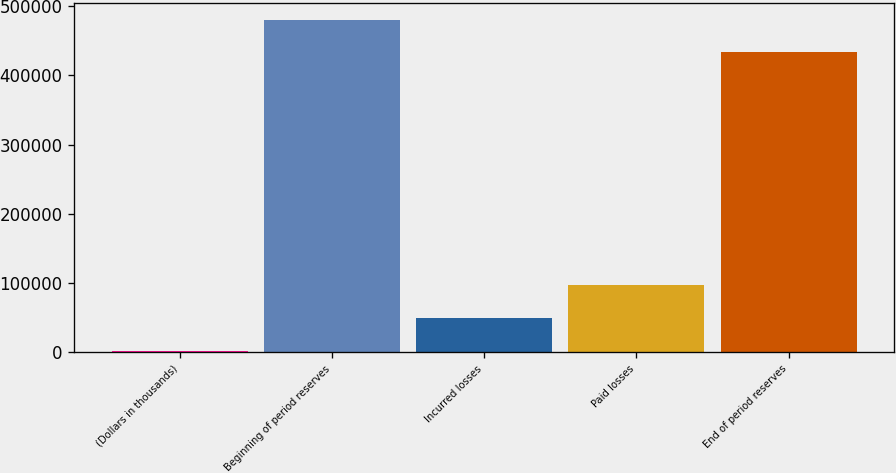Convert chart to OTSL. <chart><loc_0><loc_0><loc_500><loc_500><bar_chart><fcel>(Dollars in thousands)<fcel>Beginning of period reserves<fcel>Incurred losses<fcel>Paid losses<fcel>End of period reserves<nl><fcel>2015<fcel>480536<fcel>49434<fcel>96853<fcel>433117<nl></chart> 